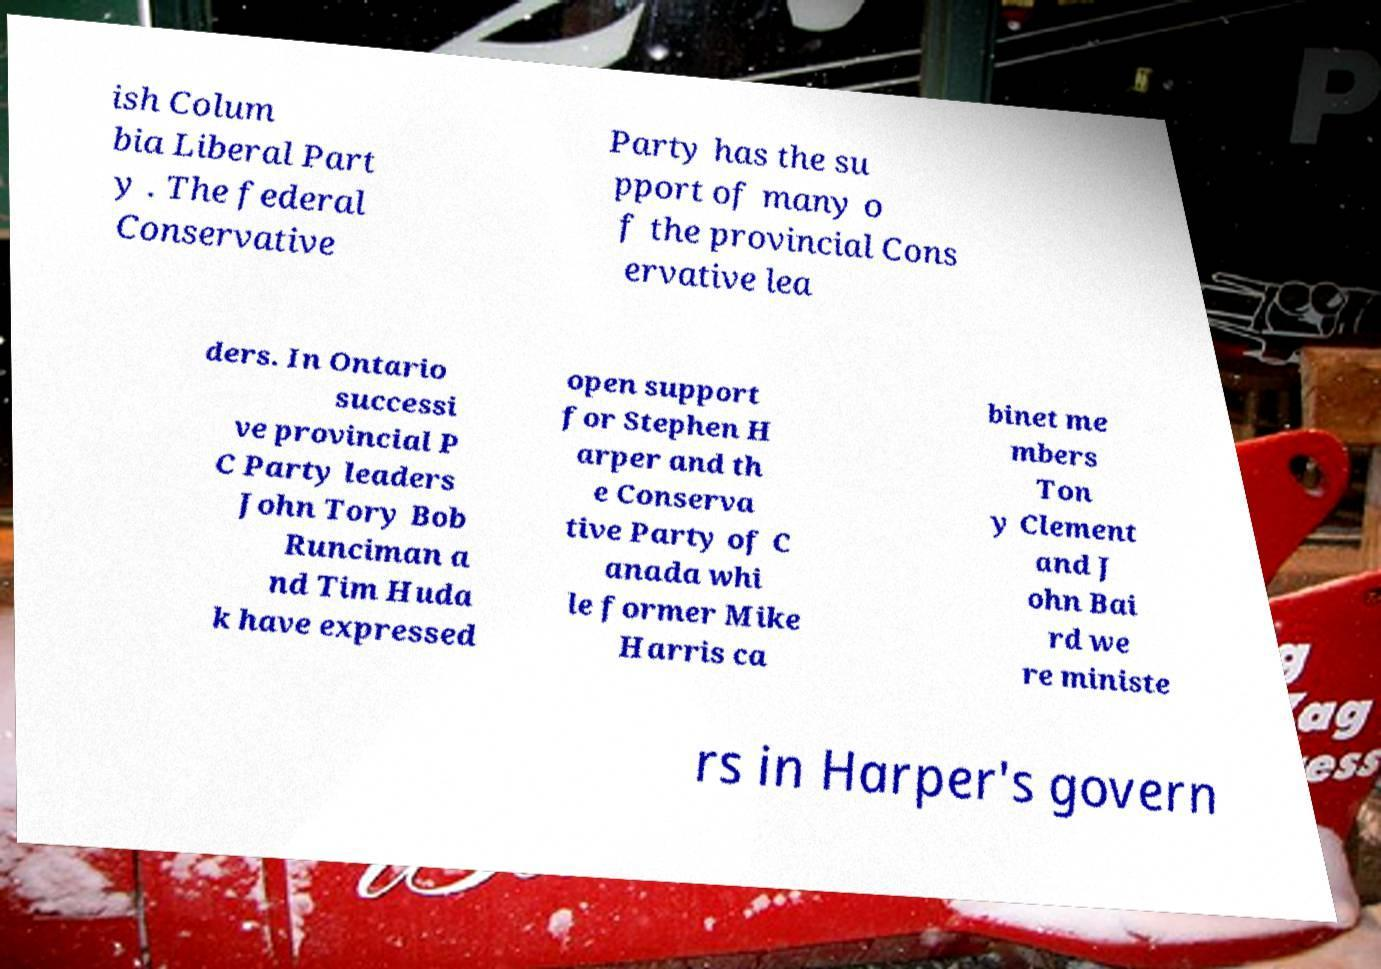Could you assist in decoding the text presented in this image and type it out clearly? ish Colum bia Liberal Part y . The federal Conservative Party has the su pport of many o f the provincial Cons ervative lea ders. In Ontario successi ve provincial P C Party leaders John Tory Bob Runciman a nd Tim Huda k have expressed open support for Stephen H arper and th e Conserva tive Party of C anada whi le former Mike Harris ca binet me mbers Ton y Clement and J ohn Bai rd we re ministe rs in Harper's govern 